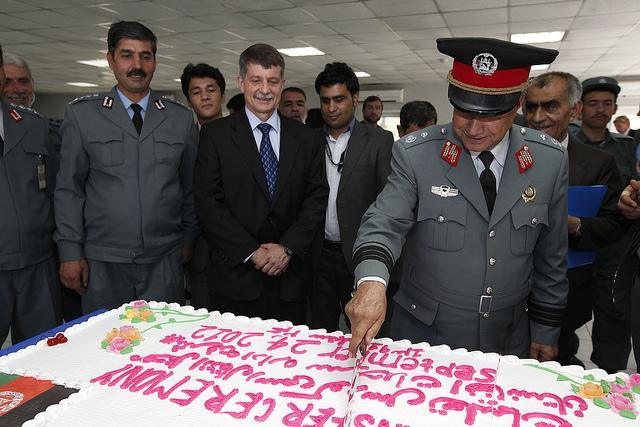Why is the man reaching towards the cake? to cut 